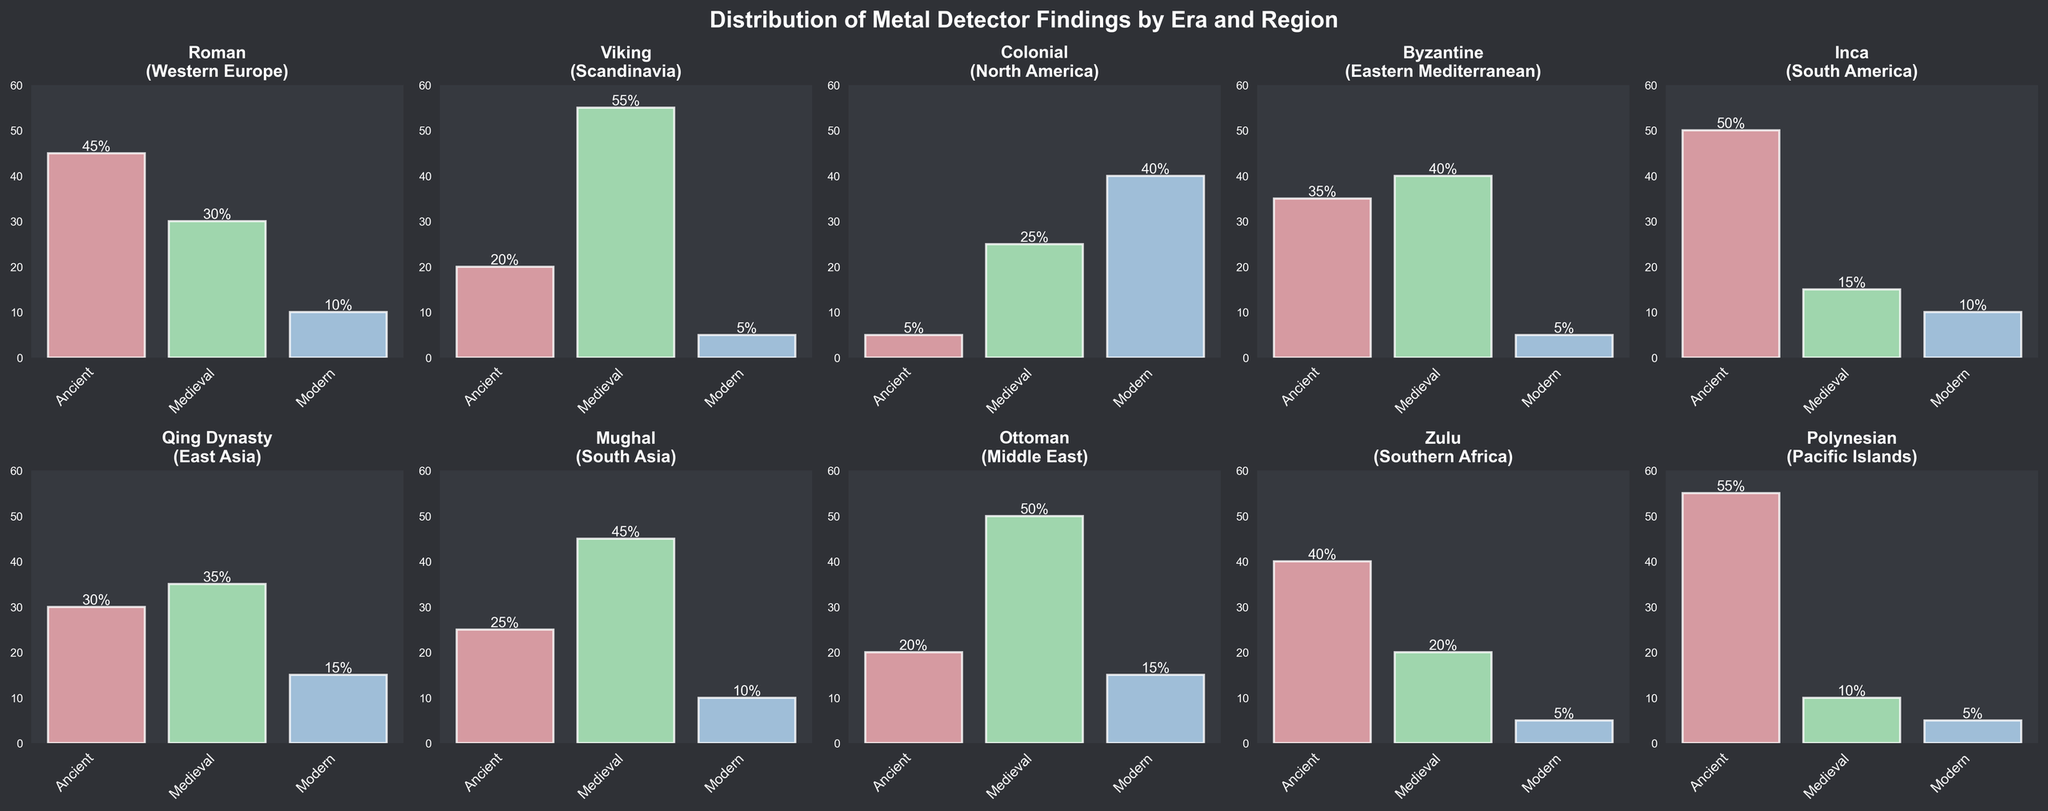What's the most common finding in Western Europe during the Roman era? Refer to the subplot for the Roman era and observe that the highest bar represents the 'Ancient' category. Therefore, the most common finding is 'Ancient'.
Answer: Ancient In which region were 'Modern' findings most common? By examining all subplots, the highest 'Modern' bar is in the North America figure (Colonial era) with 40%.
Answer: North America What is the combined total of 'Ancient' and 'Medieval' findings in the Pacific Islands? In the Polynesian era subplot, 'Ancient' findings are 55% and 'Medieval' findings are 10%. Adding these together gives 55 + 10 = 65%.
Answer: 65% Which era has the least 'Medieval' findings? Scan all the subplots for the smallest 'Medieval' bar. The Roman era (Western Europe) has the lowest 'Medieval' value with 30%.
Answer: Roman Compare the 'Ancient' findings of the Inca era with the Byzantine era. Which is higher? The subplot for the Inca era shows 'Ancient' findings at 50%, while the Byzantine era shows 'Ancient' findings at 35%. Therefore, the Inca era has higher 'Ancient' findings.
Answer: Inca How do 'Modern' findings in the Mughal era compare to those in the Qian Dynasty era? In the Mughal era subplot, 'Modern' findings are at 10%, while in the Qian Dynasty era subplot, 'Modern' findings are at 15%. 'Modern' findings are thus higher in the Qian Dynasty era.
Answer: Qian Dynasty Which regions have more than 45% 'Medieval' findings? Scan all subplots to find bars above 45% in the 'Medieval' category. Scandinavia (Viking), South Asia (Mughal), and Middle East (Ottoman) meet this criterion.
Answer: Scandinavia, South Asia, and Middle East What's the sum of 'Ancient' findings across all regions? Sum up 'Ancient' findings from each subplot: 45 (Roman) + 20 (Viking) + 5 (Colonial) + 35 (Byzantine) + 50 (Inca) + 30 (Qing Dynasty) + 25 (Mughal) + 20 (Ottoman) + 40 (Zulu) + 55 (Polynesian) = 325%.
Answer: 325% Which era has the smallest total percentage of findings? Calculate the total for each era: Roman (85), Viking (80), Colonial (70), Byzantine (80), Inca (75), Qing Dynasty (80), Mughal (80), Ottoman (85), Zulu (65), Polynesian (70). The smallest is the Zulu era with 65%.
Answer: Zulu Are 'Ancient' findings in Southern Africa higher than 'Medieval' findings in Western Europe? 'Ancient' findings in Southern Africa (Zulu era) are at 40%, while 'Medieval' findings in Western Europe (Roman era) are at 30%. Thus, 'Ancient' findings are higher in Southern Africa.
Answer: Yes 